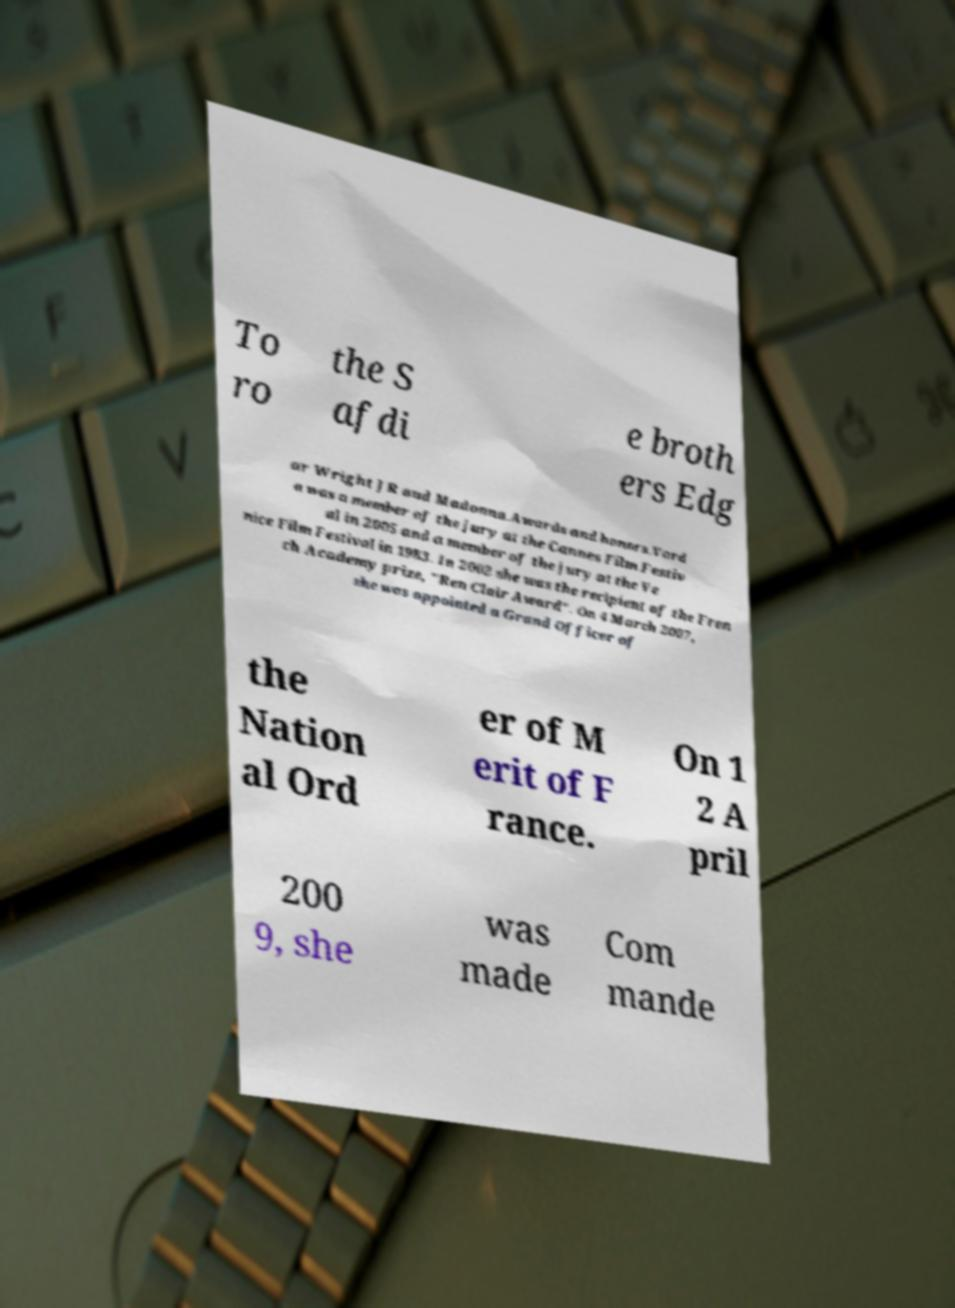Could you assist in decoding the text presented in this image and type it out clearly? To ro the S afdi e broth ers Edg ar Wright JR and Madonna.Awards and honors.Vard a was a member of the jury at the Cannes Film Festiv al in 2005 and a member of the jury at the Ve nice Film Festival in 1983. In 2002 she was the recipient of the Fren ch Academy prize, "Ren Clair Award". On 4 March 2007, she was appointed a Grand Officer of the Nation al Ord er of M erit of F rance. On 1 2 A pril 200 9, she was made Com mande 